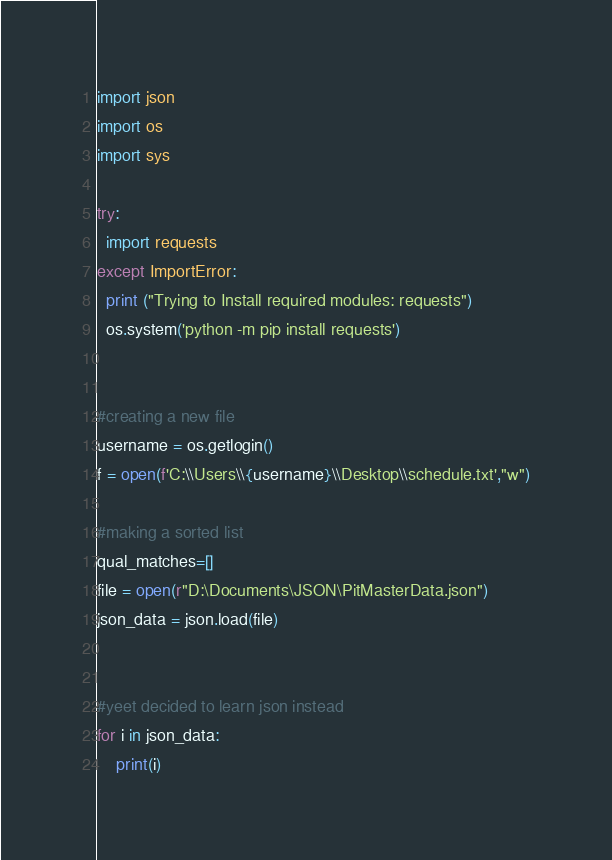Convert code to text. <code><loc_0><loc_0><loc_500><loc_500><_Python_>
import json
import os
import sys

try:
  import requests
except ImportError:
  print ("Trying to Install required modules: requests")
  os.system('python -m pip install requests')


#creating a new file
username = os.getlogin()
f = open(f'C:\\Users\\{username}\\Desktop\\schedule.txt',"w")

#making a sorted list
qual_matches=[]
file = open(r"D:\Documents\JSON\PitMasterData.json")
json_data = json.load(file)


#yeet decided to learn json instead
for i in json_data:
    print(i)


</code> 